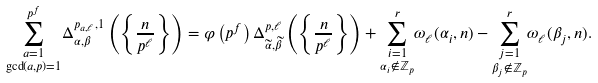Convert formula to latex. <formula><loc_0><loc_0><loc_500><loc_500>\underset { \gcd ( a , p ) = 1 } { \sum _ { a = 1 } ^ { p ^ { f } } } \Delta _ { \alpha , \beta } ^ { p _ { a , \ell } , 1 } \left ( \left \{ \frac { n } { p ^ { \ell } } \right \} \right ) = \varphi \left ( p ^ { f } \right ) \Delta _ { \widetilde { \alpha } , \widetilde { \beta } } ^ { p , \ell } \left ( \left \{ \frac { n } { p ^ { \ell } } \right \} \right ) + \underset { \alpha _ { i } \notin \mathbb { Z } _ { p } } { \sum _ { i = 1 } ^ { r } } \omega _ { \ell } ( \alpha _ { i } , n ) - \underset { \beta _ { j } \notin \mathbb { Z } _ { p } } { \sum _ { j = 1 } ^ { r } } \omega _ { \ell } ( \beta _ { j } , n ) .</formula> 